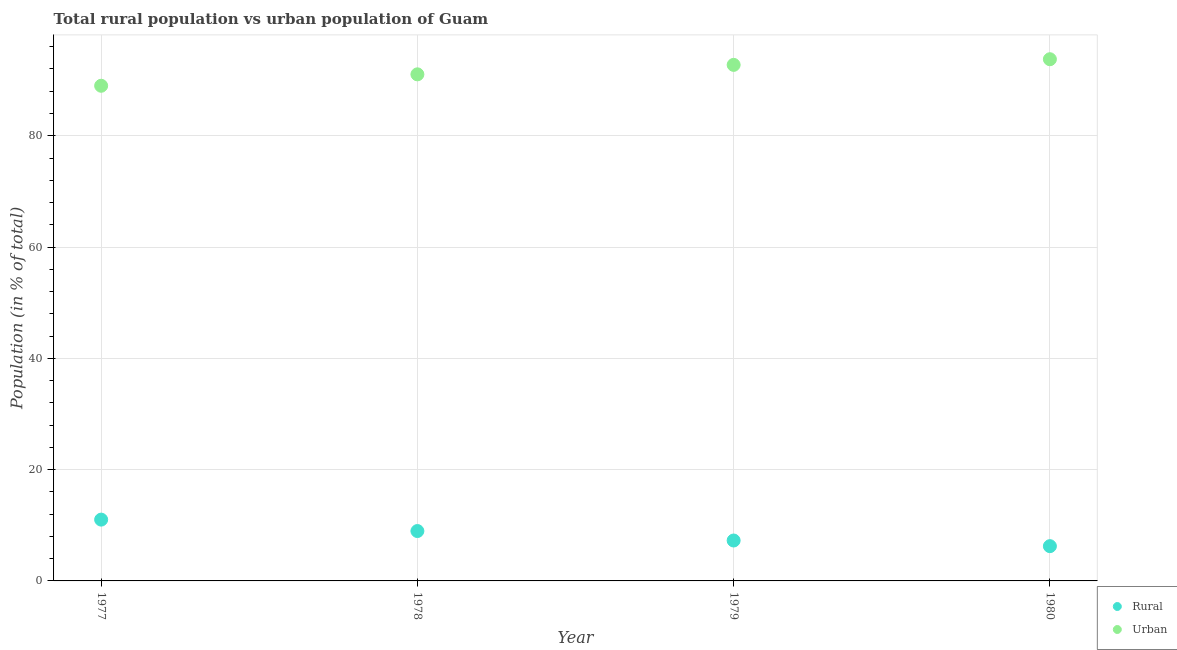How many different coloured dotlines are there?
Your answer should be compact. 2. What is the rural population in 1977?
Your answer should be compact. 11.02. Across all years, what is the maximum rural population?
Provide a short and direct response. 11.02. Across all years, what is the minimum rural population?
Give a very brief answer. 6.25. In which year was the urban population maximum?
Your answer should be compact. 1980. In which year was the urban population minimum?
Ensure brevity in your answer.  1977. What is the total rural population in the graph?
Offer a very short reply. 33.49. What is the difference between the urban population in 1977 and that in 1978?
Your answer should be compact. -2.05. What is the difference between the urban population in 1978 and the rural population in 1977?
Offer a terse response. 80.02. What is the average rural population per year?
Keep it short and to the point. 8.37. In the year 1980, what is the difference between the rural population and urban population?
Ensure brevity in your answer.  -87.51. In how many years, is the urban population greater than 20 %?
Give a very brief answer. 4. What is the ratio of the urban population in 1977 to that in 1980?
Your response must be concise. 0.95. What is the difference between the highest and the second highest urban population?
Offer a terse response. 1.02. What is the difference between the highest and the lowest rural population?
Your answer should be very brief. 4.77. Does the rural population monotonically increase over the years?
Your response must be concise. No. Is the urban population strictly greater than the rural population over the years?
Make the answer very short. Yes. Is the rural population strictly less than the urban population over the years?
Keep it short and to the point. Yes. How many years are there in the graph?
Keep it short and to the point. 4. Are the values on the major ticks of Y-axis written in scientific E-notation?
Offer a terse response. No. Does the graph contain any zero values?
Offer a very short reply. No. Does the graph contain grids?
Your answer should be very brief. Yes. How are the legend labels stacked?
Ensure brevity in your answer.  Vertical. What is the title of the graph?
Your answer should be compact. Total rural population vs urban population of Guam. What is the label or title of the X-axis?
Keep it short and to the point. Year. What is the label or title of the Y-axis?
Give a very brief answer. Population (in % of total). What is the Population (in % of total) in Rural in 1977?
Ensure brevity in your answer.  11.02. What is the Population (in % of total) of Urban in 1977?
Offer a terse response. 88.98. What is the Population (in % of total) of Rural in 1978?
Your response must be concise. 8.96. What is the Population (in % of total) in Urban in 1978?
Make the answer very short. 91.04. What is the Population (in % of total) in Rural in 1979?
Offer a terse response. 7.26. What is the Population (in % of total) in Urban in 1979?
Offer a terse response. 92.74. What is the Population (in % of total) of Rural in 1980?
Your answer should be very brief. 6.25. What is the Population (in % of total) in Urban in 1980?
Ensure brevity in your answer.  93.75. Across all years, what is the maximum Population (in % of total) of Rural?
Make the answer very short. 11.02. Across all years, what is the maximum Population (in % of total) in Urban?
Your answer should be compact. 93.75. Across all years, what is the minimum Population (in % of total) in Rural?
Make the answer very short. 6.25. Across all years, what is the minimum Population (in % of total) of Urban?
Give a very brief answer. 88.98. What is the total Population (in % of total) of Rural in the graph?
Offer a very short reply. 33.49. What is the total Population (in % of total) of Urban in the graph?
Give a very brief answer. 366.51. What is the difference between the Population (in % of total) in Rural in 1977 and that in 1978?
Provide a succinct answer. 2.05. What is the difference between the Population (in % of total) in Urban in 1977 and that in 1978?
Your answer should be compact. -2.05. What is the difference between the Population (in % of total) of Rural in 1977 and that in 1979?
Your answer should be very brief. 3.75. What is the difference between the Population (in % of total) of Urban in 1977 and that in 1979?
Provide a succinct answer. -3.75. What is the difference between the Population (in % of total) in Rural in 1977 and that in 1980?
Offer a very short reply. 4.77. What is the difference between the Population (in % of total) of Urban in 1977 and that in 1980?
Offer a terse response. -4.77. What is the difference between the Population (in % of total) of Rural in 1978 and that in 1979?
Your answer should be compact. 1.7. What is the difference between the Population (in % of total) of Urban in 1978 and that in 1979?
Give a very brief answer. -1.7. What is the difference between the Population (in % of total) of Rural in 1978 and that in 1980?
Provide a succinct answer. 2.72. What is the difference between the Population (in % of total) in Urban in 1978 and that in 1980?
Give a very brief answer. -2.72. What is the difference between the Population (in % of total) of Rural in 1979 and that in 1980?
Give a very brief answer. 1.02. What is the difference between the Population (in % of total) in Urban in 1979 and that in 1980?
Provide a succinct answer. -1.02. What is the difference between the Population (in % of total) of Rural in 1977 and the Population (in % of total) of Urban in 1978?
Your response must be concise. -80.02. What is the difference between the Population (in % of total) of Rural in 1977 and the Population (in % of total) of Urban in 1979?
Make the answer very short. -81.72. What is the difference between the Population (in % of total) in Rural in 1977 and the Population (in % of total) in Urban in 1980?
Offer a terse response. -82.74. What is the difference between the Population (in % of total) of Rural in 1978 and the Population (in % of total) of Urban in 1979?
Your response must be concise. -83.77. What is the difference between the Population (in % of total) in Rural in 1978 and the Population (in % of total) in Urban in 1980?
Your response must be concise. -84.79. What is the difference between the Population (in % of total) of Rural in 1979 and the Population (in % of total) of Urban in 1980?
Make the answer very short. -86.49. What is the average Population (in % of total) in Rural per year?
Keep it short and to the point. 8.37. What is the average Population (in % of total) of Urban per year?
Provide a short and direct response. 91.63. In the year 1977, what is the difference between the Population (in % of total) in Rural and Population (in % of total) in Urban?
Give a very brief answer. -77.97. In the year 1978, what is the difference between the Population (in % of total) of Rural and Population (in % of total) of Urban?
Give a very brief answer. -82.07. In the year 1979, what is the difference between the Population (in % of total) in Rural and Population (in % of total) in Urban?
Keep it short and to the point. -85.47. In the year 1980, what is the difference between the Population (in % of total) of Rural and Population (in % of total) of Urban?
Ensure brevity in your answer.  -87.51. What is the ratio of the Population (in % of total) in Rural in 1977 to that in 1978?
Offer a terse response. 1.23. What is the ratio of the Population (in % of total) in Urban in 1977 to that in 1978?
Offer a very short reply. 0.98. What is the ratio of the Population (in % of total) in Rural in 1977 to that in 1979?
Your answer should be very brief. 1.52. What is the ratio of the Population (in % of total) of Urban in 1977 to that in 1979?
Ensure brevity in your answer.  0.96. What is the ratio of the Population (in % of total) in Rural in 1977 to that in 1980?
Your response must be concise. 1.76. What is the ratio of the Population (in % of total) in Urban in 1977 to that in 1980?
Ensure brevity in your answer.  0.95. What is the ratio of the Population (in % of total) of Rural in 1978 to that in 1979?
Provide a succinct answer. 1.23. What is the ratio of the Population (in % of total) of Urban in 1978 to that in 1979?
Your response must be concise. 0.98. What is the ratio of the Population (in % of total) of Rural in 1978 to that in 1980?
Provide a short and direct response. 1.43. What is the ratio of the Population (in % of total) of Urban in 1978 to that in 1980?
Offer a terse response. 0.97. What is the ratio of the Population (in % of total) of Rural in 1979 to that in 1980?
Ensure brevity in your answer.  1.16. What is the ratio of the Population (in % of total) of Urban in 1979 to that in 1980?
Offer a very short reply. 0.99. What is the difference between the highest and the second highest Population (in % of total) in Rural?
Offer a very short reply. 2.05. What is the difference between the highest and the second highest Population (in % of total) of Urban?
Make the answer very short. 1.02. What is the difference between the highest and the lowest Population (in % of total) of Rural?
Your answer should be very brief. 4.77. What is the difference between the highest and the lowest Population (in % of total) in Urban?
Offer a very short reply. 4.77. 